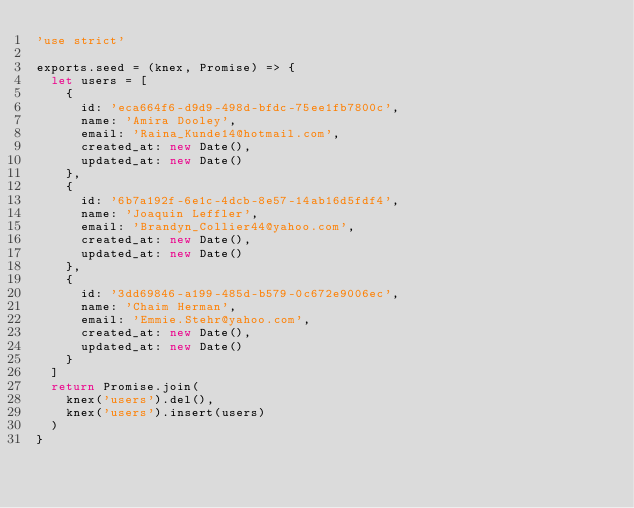<code> <loc_0><loc_0><loc_500><loc_500><_JavaScript_>'use strict'

exports.seed = (knex, Promise) => {
  let users = [
    {
      id: 'eca664f6-d9d9-498d-bfdc-75ee1fb7800c',
      name: 'Amira Dooley',
      email: 'Raina_Kunde14@hotmail.com',
      created_at: new Date(),
      updated_at: new Date()
    },
    {
      id: '6b7a192f-6e1c-4dcb-8e57-14ab16d5fdf4',
      name: 'Joaquin Leffler',
      email: 'Brandyn_Collier44@yahoo.com',
      created_at: new Date(),
      updated_at: new Date()
    },
    {
      id: '3dd69846-a199-485d-b579-0c672e9006ec',
      name: 'Chaim Herman',
      email: 'Emmie.Stehr@yahoo.com',
      created_at: new Date(),
      updated_at: new Date()
    }
  ]
  return Promise.join(
    knex('users').del(),
    knex('users').insert(users)
  )
}
</code> 